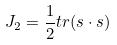<formula> <loc_0><loc_0><loc_500><loc_500>J _ { 2 } = \frac { 1 } { 2 } t r ( s \cdot s )</formula> 